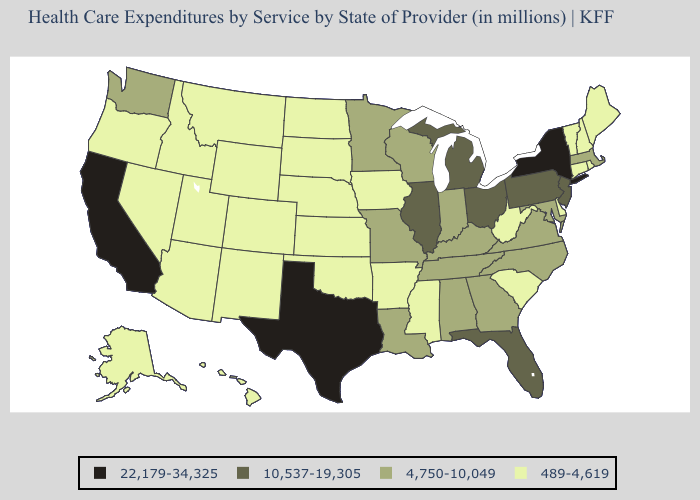Which states have the lowest value in the USA?
Keep it brief. Alaska, Arizona, Arkansas, Colorado, Connecticut, Delaware, Hawaii, Idaho, Iowa, Kansas, Maine, Mississippi, Montana, Nebraska, Nevada, New Hampshire, New Mexico, North Dakota, Oklahoma, Oregon, Rhode Island, South Carolina, South Dakota, Utah, Vermont, West Virginia, Wyoming. What is the highest value in states that border Idaho?
Short answer required. 4,750-10,049. Which states hav the highest value in the MidWest?
Keep it brief. Illinois, Michigan, Ohio. Name the states that have a value in the range 10,537-19,305?
Keep it brief. Florida, Illinois, Michigan, New Jersey, Ohio, Pennsylvania. Which states have the lowest value in the Northeast?
Write a very short answer. Connecticut, Maine, New Hampshire, Rhode Island, Vermont. What is the highest value in the South ?
Keep it brief. 22,179-34,325. Name the states that have a value in the range 10,537-19,305?
Be succinct. Florida, Illinois, Michigan, New Jersey, Ohio, Pennsylvania. What is the value of Mississippi?
Write a very short answer. 489-4,619. Does Illinois have the lowest value in the USA?
Answer briefly. No. Does Minnesota have the highest value in the USA?
Write a very short answer. No. Among the states that border Indiana , which have the highest value?
Quick response, please. Illinois, Michigan, Ohio. What is the lowest value in the West?
Concise answer only. 489-4,619. Does Alabama have the lowest value in the USA?
Answer briefly. No. What is the highest value in the Northeast ?
Be succinct. 22,179-34,325. Is the legend a continuous bar?
Write a very short answer. No. 